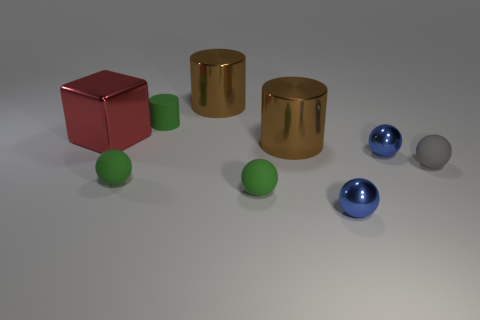What number of rubber objects are tiny green spheres or tiny gray things?
Keep it short and to the point. 3. Is there any other thing that is the same size as the gray rubber object?
Offer a very short reply. Yes. There is a red shiny thing; does it have the same size as the blue shiny ball behind the tiny gray matte ball?
Ensure brevity in your answer.  No. What shape is the matte object behind the small gray matte ball?
Give a very brief answer. Cylinder. There is a shiny object in front of the small metal object behind the gray rubber object; what color is it?
Give a very brief answer. Blue. How many things are the same color as the small cylinder?
Keep it short and to the point. 2. There is a rubber cylinder; does it have the same color as the small metal thing that is in front of the small gray thing?
Your answer should be compact. No. What is the shape of the thing that is both to the right of the small cylinder and behind the big metal block?
Give a very brief answer. Cylinder. There is a large red block that is behind the tiny shiny sphere that is behind the small blue object in front of the tiny gray thing; what is it made of?
Provide a succinct answer. Metal. Is the number of rubber cylinders to the right of the matte cylinder greater than the number of tiny green cylinders behind the red shiny cube?
Keep it short and to the point. No. 